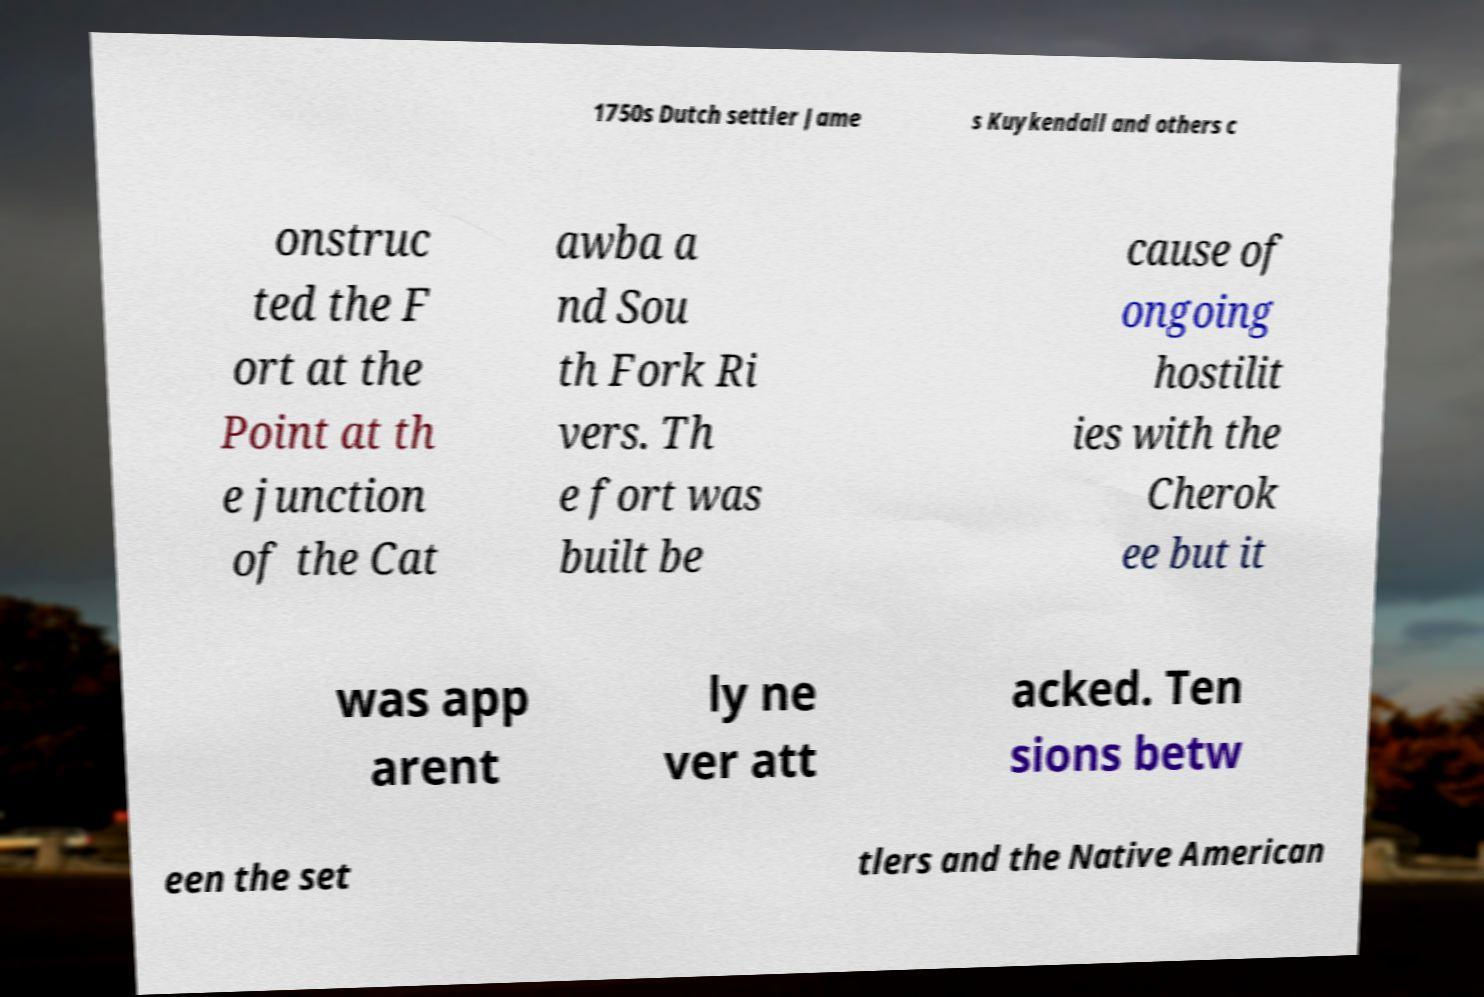Could you assist in decoding the text presented in this image and type it out clearly? 1750s Dutch settler Jame s Kuykendall and others c onstruc ted the F ort at the Point at th e junction of the Cat awba a nd Sou th Fork Ri vers. Th e fort was built be cause of ongoing hostilit ies with the Cherok ee but it was app arent ly ne ver att acked. Ten sions betw een the set tlers and the Native American 